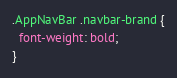Convert code to text. <code><loc_0><loc_0><loc_500><loc_500><_CSS_>.AppNavBar .navbar-brand {
  font-weight: bold;
}
</code> 